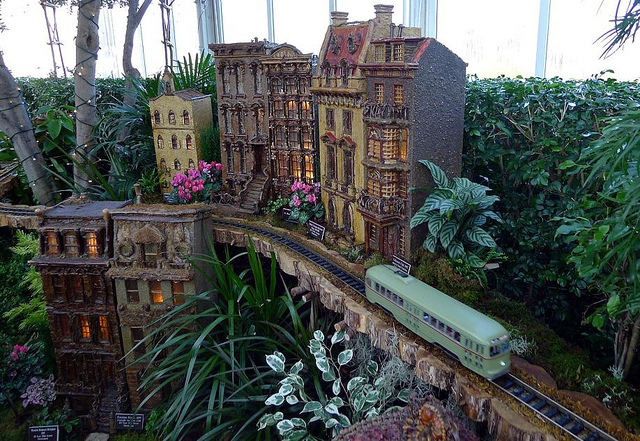<image>What is the means of propulsion for the train? I don't know what is the means of propulsion for the train. It might be electric or battery powered. What is the means of propulsion for the train? I don't know the means of propulsion for the train. It can be batteries, small motor, tracks, or electricity. 